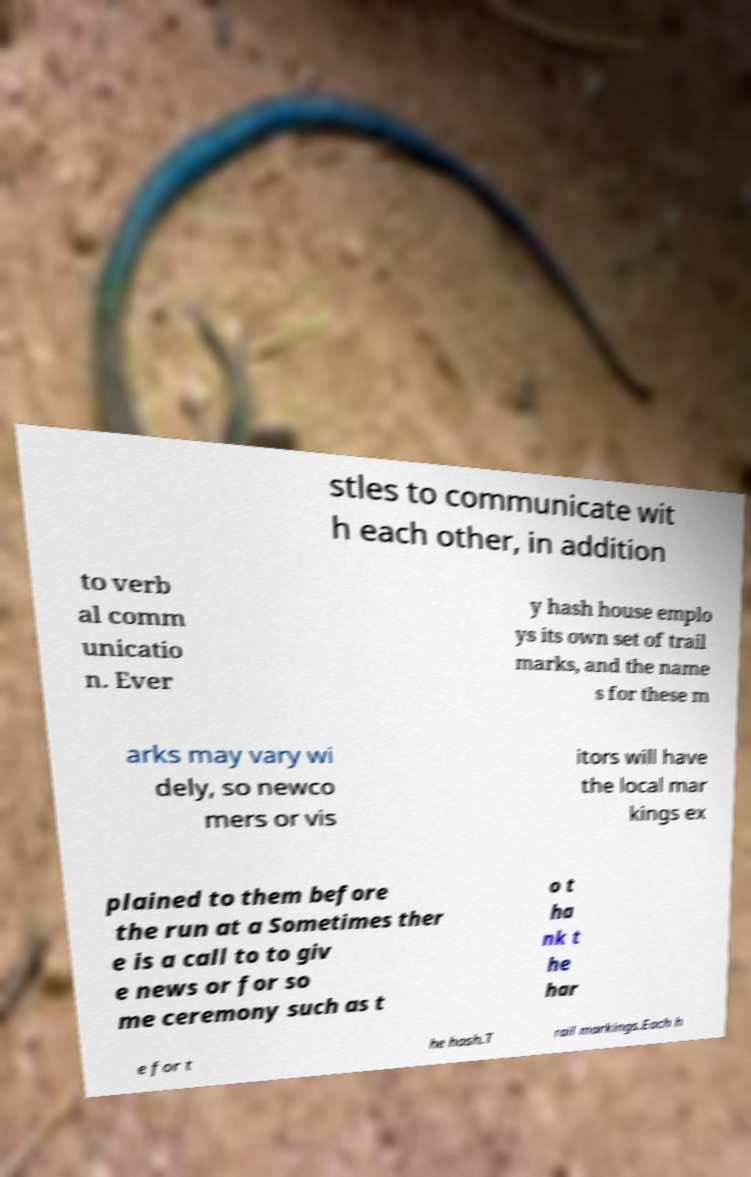For documentation purposes, I need the text within this image transcribed. Could you provide that? stles to communicate wit h each other, in addition to verb al comm unicatio n. Ever y hash house emplo ys its own set of trail marks, and the name s for these m arks may vary wi dely, so newco mers or vis itors will have the local mar kings ex plained to them before the run at a Sometimes ther e is a call to to giv e news or for so me ceremony such as t o t ha nk t he har e for t he hash.T rail markings.Each h 